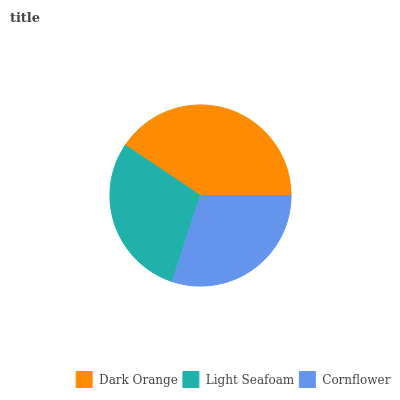Is Light Seafoam the minimum?
Answer yes or no. Yes. Is Dark Orange the maximum?
Answer yes or no. Yes. Is Cornflower the minimum?
Answer yes or no. No. Is Cornflower the maximum?
Answer yes or no. No. Is Cornflower greater than Light Seafoam?
Answer yes or no. Yes. Is Light Seafoam less than Cornflower?
Answer yes or no. Yes. Is Light Seafoam greater than Cornflower?
Answer yes or no. No. Is Cornflower less than Light Seafoam?
Answer yes or no. No. Is Cornflower the high median?
Answer yes or no. Yes. Is Cornflower the low median?
Answer yes or no. Yes. Is Dark Orange the high median?
Answer yes or no. No. Is Light Seafoam the low median?
Answer yes or no. No. 